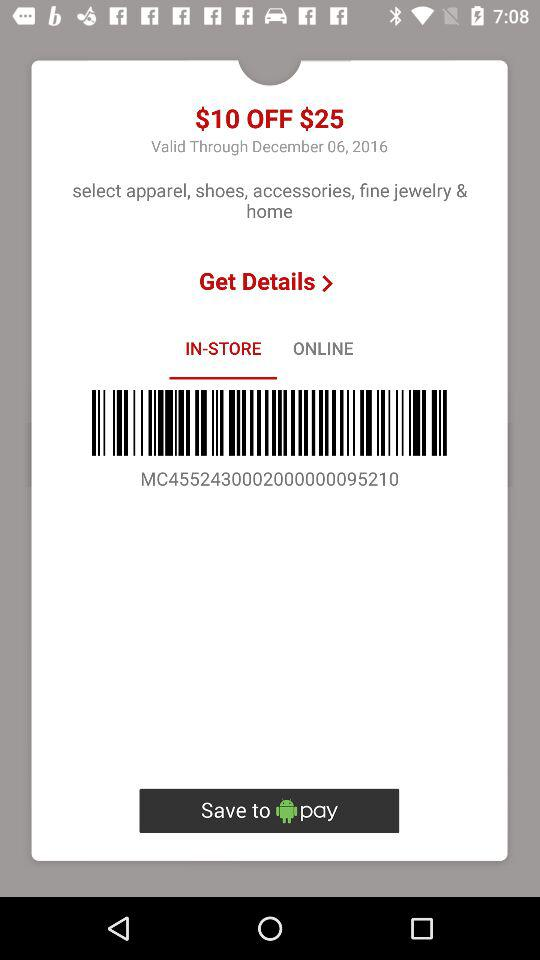What tab is selected? The selected tab is "IN-STORE". 